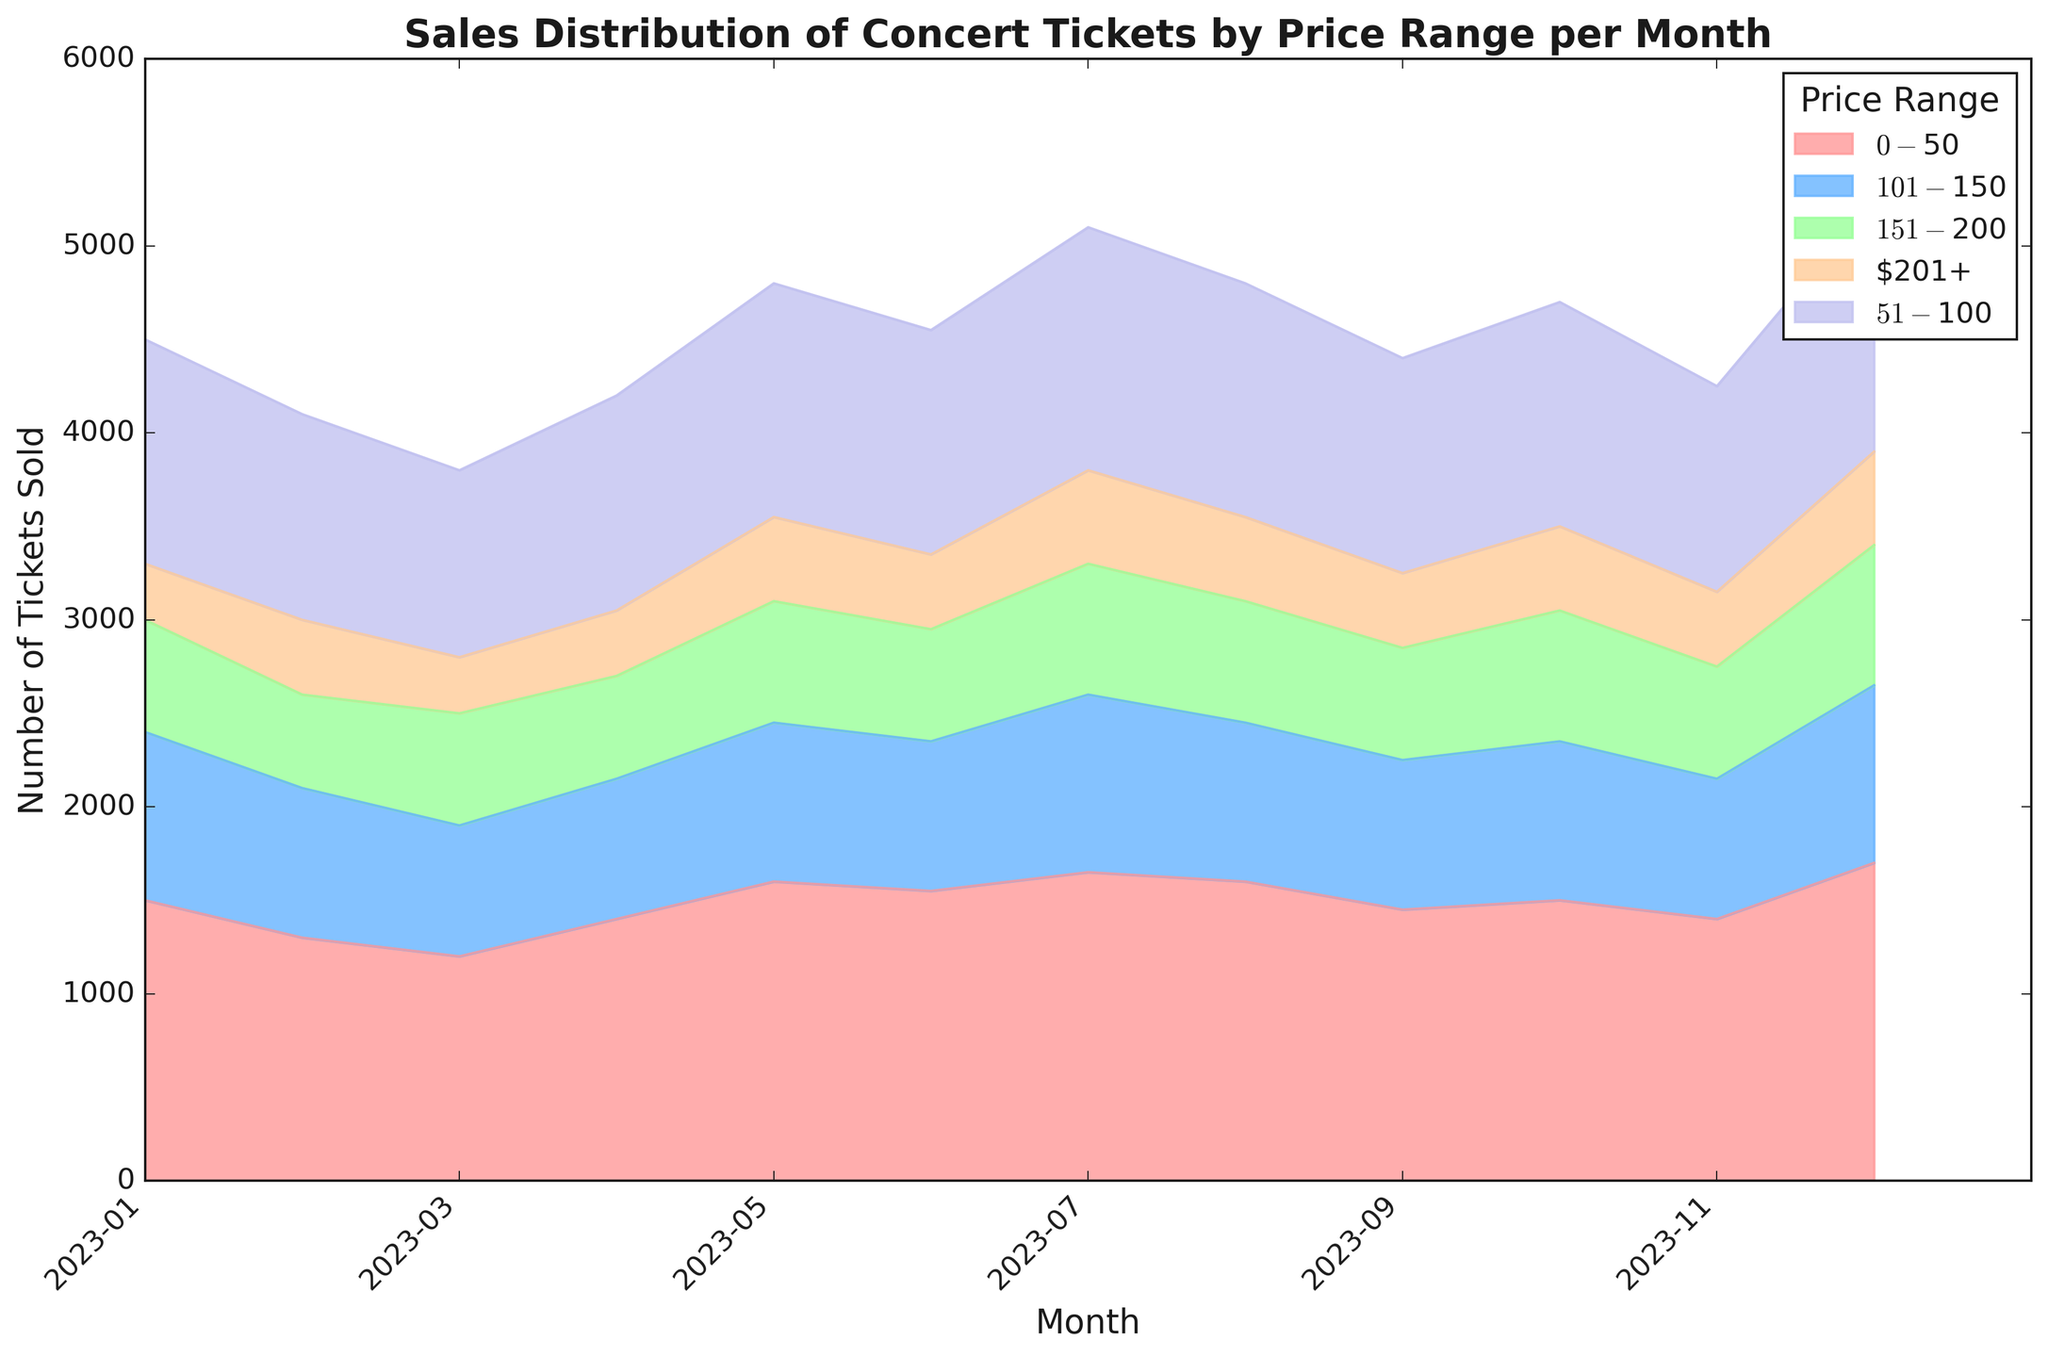What is the total number of tickets sold in May? To find the total number of tickets sold in May, we need to sum the values for each price range in May. The values are 1600, 1250, 850, 650, and 450. Summing these up gives 1600 + 1250 + 850 + 650 + 450 = 4800
Answer: 4800 Which price range had the highest sales in December? Look at the figure and identify the highest point for the month of December. In December, the price range $0-$50 has the highest sales, represented by the largest area at the top.
Answer: $0-$50 How did the sales of the $51-$100 price range change from February to July? To answer this, compare the sales values in February (1100) and July (1300). The sales increased from 1100 to 1300.
Answer: Increased by 200 For which month did the $101-$150 price range see the lowest sales? Check for the lowest value of sales in the $101-$150 price range across all months. The lowest sales are in March, with 700 tickets sold.
Answer: March Is there a noticeable trend in the sales of tickets priced $201+ over the year? Examine the sales values for the $201+ price range from January to December. Sales values oscillate with no clear upward or downward trend: starting at 300 in January, slightly fluctuating, but ending at 500 in December.
Answer: No noticeable trend What is the difference in total sales between the months with the highest and lowest total sales? Identify the months with the highest (December; 5200) and lowest (March; 3900) total sales, then find their difference: 5200 - 3900 = 1300
Answer: 1300 Which month had the most balanced distribution of ticket sales across all price ranges? The most balanced distribution would have price range areas with similar heights in one month. Observing the chart, May or October appears fairly balanced where the areas are not too divergent compared to other months.
Answer: May or October What was the average number of tickets sold for $0-$50 through the year? Sum the sales for the $0-$50 price range for all months and divide by 12. The total is 1500 + 1300 + 1200 + 1400 + 1600 + 1550 + 1650 + 1600 + 1450 + 1500 + 1400 + 1700 = 18850. The average is 18850/12 ≈ 1571.
Answer: 1571 